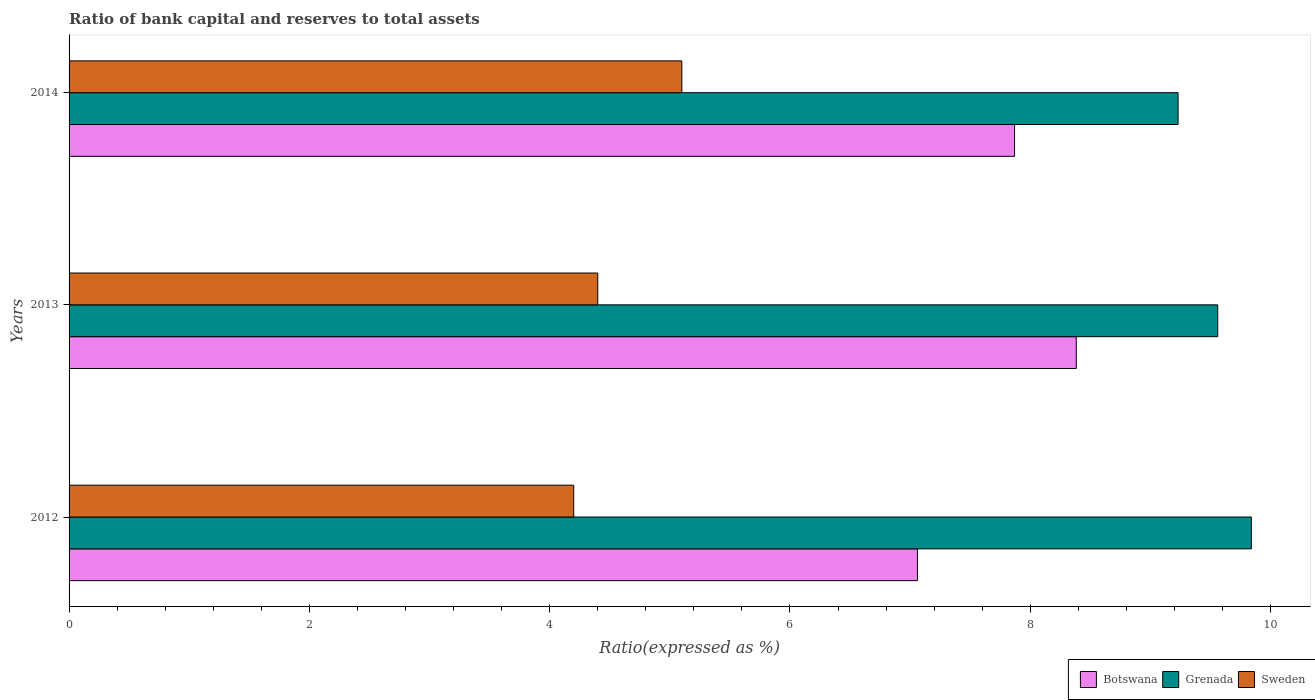How many groups of bars are there?
Provide a succinct answer. 3. In how many cases, is the number of bars for a given year not equal to the number of legend labels?
Provide a succinct answer. 0. What is the ratio of bank capital and reserves to total assets in Grenada in 2013?
Provide a short and direct response. 9.56. Across all years, what is the maximum ratio of bank capital and reserves to total assets in Grenada?
Your answer should be compact. 9.84. Across all years, what is the minimum ratio of bank capital and reserves to total assets in Sweden?
Offer a very short reply. 4.2. In which year was the ratio of bank capital and reserves to total assets in Sweden maximum?
Keep it short and to the point. 2014. What is the total ratio of bank capital and reserves to total assets in Grenada in the graph?
Ensure brevity in your answer.  28.63. What is the difference between the ratio of bank capital and reserves to total assets in Sweden in 2013 and that in 2014?
Your response must be concise. -0.7. What is the difference between the ratio of bank capital and reserves to total assets in Grenada in 2013 and the ratio of bank capital and reserves to total assets in Botswana in 2012?
Provide a succinct answer. 2.5. What is the average ratio of bank capital and reserves to total assets in Sweden per year?
Keep it short and to the point. 4.57. In the year 2013, what is the difference between the ratio of bank capital and reserves to total assets in Sweden and ratio of bank capital and reserves to total assets in Botswana?
Offer a very short reply. -3.98. In how many years, is the ratio of bank capital and reserves to total assets in Grenada greater than 8 %?
Keep it short and to the point. 3. What is the ratio of the ratio of bank capital and reserves to total assets in Botswana in 2012 to that in 2014?
Offer a very short reply. 0.9. What is the difference between the highest and the second highest ratio of bank capital and reserves to total assets in Grenada?
Your answer should be compact. 0.28. What is the difference between the highest and the lowest ratio of bank capital and reserves to total assets in Sweden?
Your answer should be very brief. 0.9. In how many years, is the ratio of bank capital and reserves to total assets in Grenada greater than the average ratio of bank capital and reserves to total assets in Grenada taken over all years?
Your answer should be compact. 2. Is the sum of the ratio of bank capital and reserves to total assets in Grenada in 2012 and 2014 greater than the maximum ratio of bank capital and reserves to total assets in Botswana across all years?
Make the answer very short. Yes. What does the 3rd bar from the top in 2013 represents?
Ensure brevity in your answer.  Botswana. What does the 2nd bar from the bottom in 2013 represents?
Ensure brevity in your answer.  Grenada. Is it the case that in every year, the sum of the ratio of bank capital and reserves to total assets in Botswana and ratio of bank capital and reserves to total assets in Sweden is greater than the ratio of bank capital and reserves to total assets in Grenada?
Offer a terse response. Yes. What is the difference between two consecutive major ticks on the X-axis?
Ensure brevity in your answer.  2. Does the graph contain any zero values?
Give a very brief answer. No. Does the graph contain grids?
Offer a very short reply. No. How are the legend labels stacked?
Your answer should be compact. Horizontal. What is the title of the graph?
Provide a succinct answer. Ratio of bank capital and reserves to total assets. What is the label or title of the X-axis?
Offer a terse response. Ratio(expressed as %). What is the label or title of the Y-axis?
Offer a very short reply. Years. What is the Ratio(expressed as %) of Botswana in 2012?
Make the answer very short. 7.06. What is the Ratio(expressed as %) in Grenada in 2012?
Offer a very short reply. 9.84. What is the Ratio(expressed as %) in Sweden in 2012?
Ensure brevity in your answer.  4.2. What is the Ratio(expressed as %) in Botswana in 2013?
Give a very brief answer. 8.38. What is the Ratio(expressed as %) of Grenada in 2013?
Ensure brevity in your answer.  9.56. What is the Ratio(expressed as %) in Botswana in 2014?
Offer a terse response. 7.87. What is the Ratio(expressed as %) in Grenada in 2014?
Your answer should be compact. 9.23. Across all years, what is the maximum Ratio(expressed as %) in Botswana?
Offer a terse response. 8.38. Across all years, what is the maximum Ratio(expressed as %) in Grenada?
Offer a very short reply. 9.84. Across all years, what is the minimum Ratio(expressed as %) of Botswana?
Keep it short and to the point. 7.06. Across all years, what is the minimum Ratio(expressed as %) of Grenada?
Offer a very short reply. 9.23. Across all years, what is the minimum Ratio(expressed as %) in Sweden?
Ensure brevity in your answer.  4.2. What is the total Ratio(expressed as %) in Botswana in the graph?
Provide a succinct answer. 23.31. What is the total Ratio(expressed as %) in Grenada in the graph?
Give a very brief answer. 28.63. What is the total Ratio(expressed as %) of Sweden in the graph?
Keep it short and to the point. 13.7. What is the difference between the Ratio(expressed as %) of Botswana in 2012 and that in 2013?
Provide a short and direct response. -1.32. What is the difference between the Ratio(expressed as %) in Grenada in 2012 and that in 2013?
Provide a short and direct response. 0.28. What is the difference between the Ratio(expressed as %) in Sweden in 2012 and that in 2013?
Your response must be concise. -0.2. What is the difference between the Ratio(expressed as %) in Botswana in 2012 and that in 2014?
Provide a succinct answer. -0.81. What is the difference between the Ratio(expressed as %) in Grenada in 2012 and that in 2014?
Your response must be concise. 0.61. What is the difference between the Ratio(expressed as %) of Sweden in 2012 and that in 2014?
Offer a very short reply. -0.9. What is the difference between the Ratio(expressed as %) of Botswana in 2013 and that in 2014?
Keep it short and to the point. 0.51. What is the difference between the Ratio(expressed as %) of Grenada in 2013 and that in 2014?
Ensure brevity in your answer.  0.33. What is the difference between the Ratio(expressed as %) of Botswana in 2012 and the Ratio(expressed as %) of Grenada in 2013?
Your answer should be very brief. -2.5. What is the difference between the Ratio(expressed as %) of Botswana in 2012 and the Ratio(expressed as %) of Sweden in 2013?
Give a very brief answer. 2.66. What is the difference between the Ratio(expressed as %) in Grenada in 2012 and the Ratio(expressed as %) in Sweden in 2013?
Provide a succinct answer. 5.44. What is the difference between the Ratio(expressed as %) in Botswana in 2012 and the Ratio(expressed as %) in Grenada in 2014?
Your answer should be compact. -2.17. What is the difference between the Ratio(expressed as %) in Botswana in 2012 and the Ratio(expressed as %) in Sweden in 2014?
Offer a terse response. 1.96. What is the difference between the Ratio(expressed as %) of Grenada in 2012 and the Ratio(expressed as %) of Sweden in 2014?
Your response must be concise. 4.74. What is the difference between the Ratio(expressed as %) in Botswana in 2013 and the Ratio(expressed as %) in Grenada in 2014?
Offer a terse response. -0.85. What is the difference between the Ratio(expressed as %) in Botswana in 2013 and the Ratio(expressed as %) in Sweden in 2014?
Your answer should be compact. 3.28. What is the difference between the Ratio(expressed as %) of Grenada in 2013 and the Ratio(expressed as %) of Sweden in 2014?
Your answer should be compact. 4.46. What is the average Ratio(expressed as %) of Botswana per year?
Offer a terse response. 7.77. What is the average Ratio(expressed as %) in Grenada per year?
Your response must be concise. 9.54. What is the average Ratio(expressed as %) in Sweden per year?
Make the answer very short. 4.57. In the year 2012, what is the difference between the Ratio(expressed as %) in Botswana and Ratio(expressed as %) in Grenada?
Provide a short and direct response. -2.78. In the year 2012, what is the difference between the Ratio(expressed as %) in Botswana and Ratio(expressed as %) in Sweden?
Make the answer very short. 2.86. In the year 2012, what is the difference between the Ratio(expressed as %) of Grenada and Ratio(expressed as %) of Sweden?
Offer a terse response. 5.64. In the year 2013, what is the difference between the Ratio(expressed as %) in Botswana and Ratio(expressed as %) in Grenada?
Provide a succinct answer. -1.18. In the year 2013, what is the difference between the Ratio(expressed as %) of Botswana and Ratio(expressed as %) of Sweden?
Offer a very short reply. 3.98. In the year 2013, what is the difference between the Ratio(expressed as %) of Grenada and Ratio(expressed as %) of Sweden?
Provide a short and direct response. 5.16. In the year 2014, what is the difference between the Ratio(expressed as %) of Botswana and Ratio(expressed as %) of Grenada?
Keep it short and to the point. -1.36. In the year 2014, what is the difference between the Ratio(expressed as %) of Botswana and Ratio(expressed as %) of Sweden?
Ensure brevity in your answer.  2.77. In the year 2014, what is the difference between the Ratio(expressed as %) of Grenada and Ratio(expressed as %) of Sweden?
Provide a succinct answer. 4.13. What is the ratio of the Ratio(expressed as %) of Botswana in 2012 to that in 2013?
Give a very brief answer. 0.84. What is the ratio of the Ratio(expressed as %) of Grenada in 2012 to that in 2013?
Your answer should be very brief. 1.03. What is the ratio of the Ratio(expressed as %) of Sweden in 2012 to that in 2013?
Keep it short and to the point. 0.95. What is the ratio of the Ratio(expressed as %) in Botswana in 2012 to that in 2014?
Your answer should be very brief. 0.9. What is the ratio of the Ratio(expressed as %) in Grenada in 2012 to that in 2014?
Your response must be concise. 1.07. What is the ratio of the Ratio(expressed as %) of Sweden in 2012 to that in 2014?
Keep it short and to the point. 0.82. What is the ratio of the Ratio(expressed as %) of Botswana in 2013 to that in 2014?
Provide a succinct answer. 1.07. What is the ratio of the Ratio(expressed as %) in Grenada in 2013 to that in 2014?
Your answer should be very brief. 1.04. What is the ratio of the Ratio(expressed as %) in Sweden in 2013 to that in 2014?
Ensure brevity in your answer.  0.86. What is the difference between the highest and the second highest Ratio(expressed as %) of Botswana?
Make the answer very short. 0.51. What is the difference between the highest and the second highest Ratio(expressed as %) in Grenada?
Keep it short and to the point. 0.28. What is the difference between the highest and the second highest Ratio(expressed as %) of Sweden?
Your response must be concise. 0.7. What is the difference between the highest and the lowest Ratio(expressed as %) of Botswana?
Keep it short and to the point. 1.32. What is the difference between the highest and the lowest Ratio(expressed as %) of Grenada?
Keep it short and to the point. 0.61. 